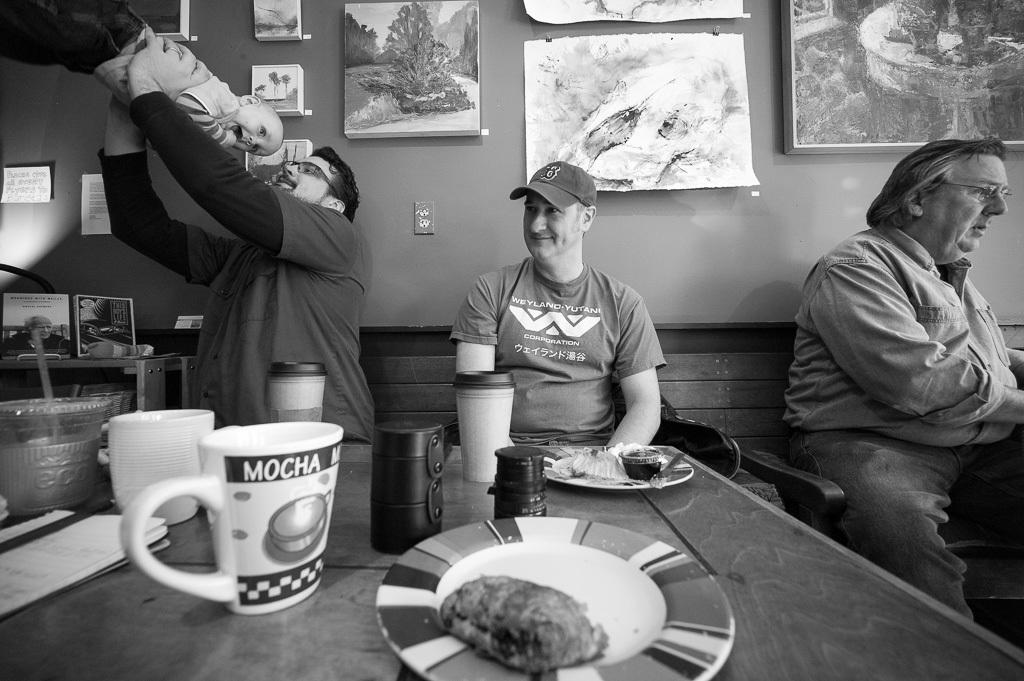How many people are in the image? There are three men in the image. Where are the men located? The men are in a coffee shop. What are the men doing in the image? One of the men is playing with a boy. What type of quiver can be seen in the image? There is no quiver present in the image. How does the spoon contribute to the scene in the image? There is no spoon mentioned in the image, so it cannot contribute to the scene. 